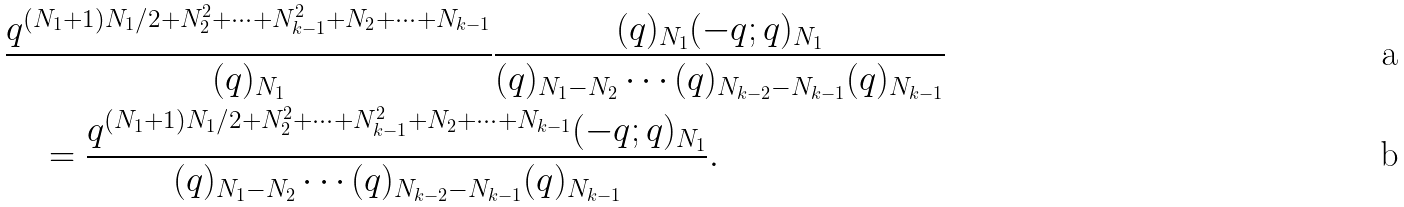<formula> <loc_0><loc_0><loc_500><loc_500>& \frac { q ^ { ( N _ { 1 } + 1 ) N _ { 1 } / 2 + N ^ { 2 } _ { 2 } + \cdots + N _ { k - 1 } ^ { 2 } + N _ { 2 } + \cdots + N _ { k - 1 } } } { ( q ) _ { N _ { 1 } } } \frac { ( q ) _ { N _ { 1 } } ( - q ; q ) _ { N _ { 1 } } } { ( q ) _ { N _ { 1 } - N _ { 2 } } \cdots ( q ) _ { N _ { k - 2 } - N _ { k - 1 } } ( q ) _ { N _ { k - 1 } } } \\ & \quad = \frac { q ^ { ( N _ { 1 } + 1 ) N _ { 1 } / 2 + N ^ { 2 } _ { 2 } + \cdots + N _ { k - 1 } ^ { 2 } + N _ { 2 } + \cdots + N _ { k - 1 } } ( - q ; q ) _ { N _ { 1 } } } { ( q ) _ { N _ { 1 } - N _ { 2 } } \cdots ( q ) _ { N _ { k - 2 } - N _ { k - 1 } } ( q ) _ { N _ { k - 1 } } } .</formula> 